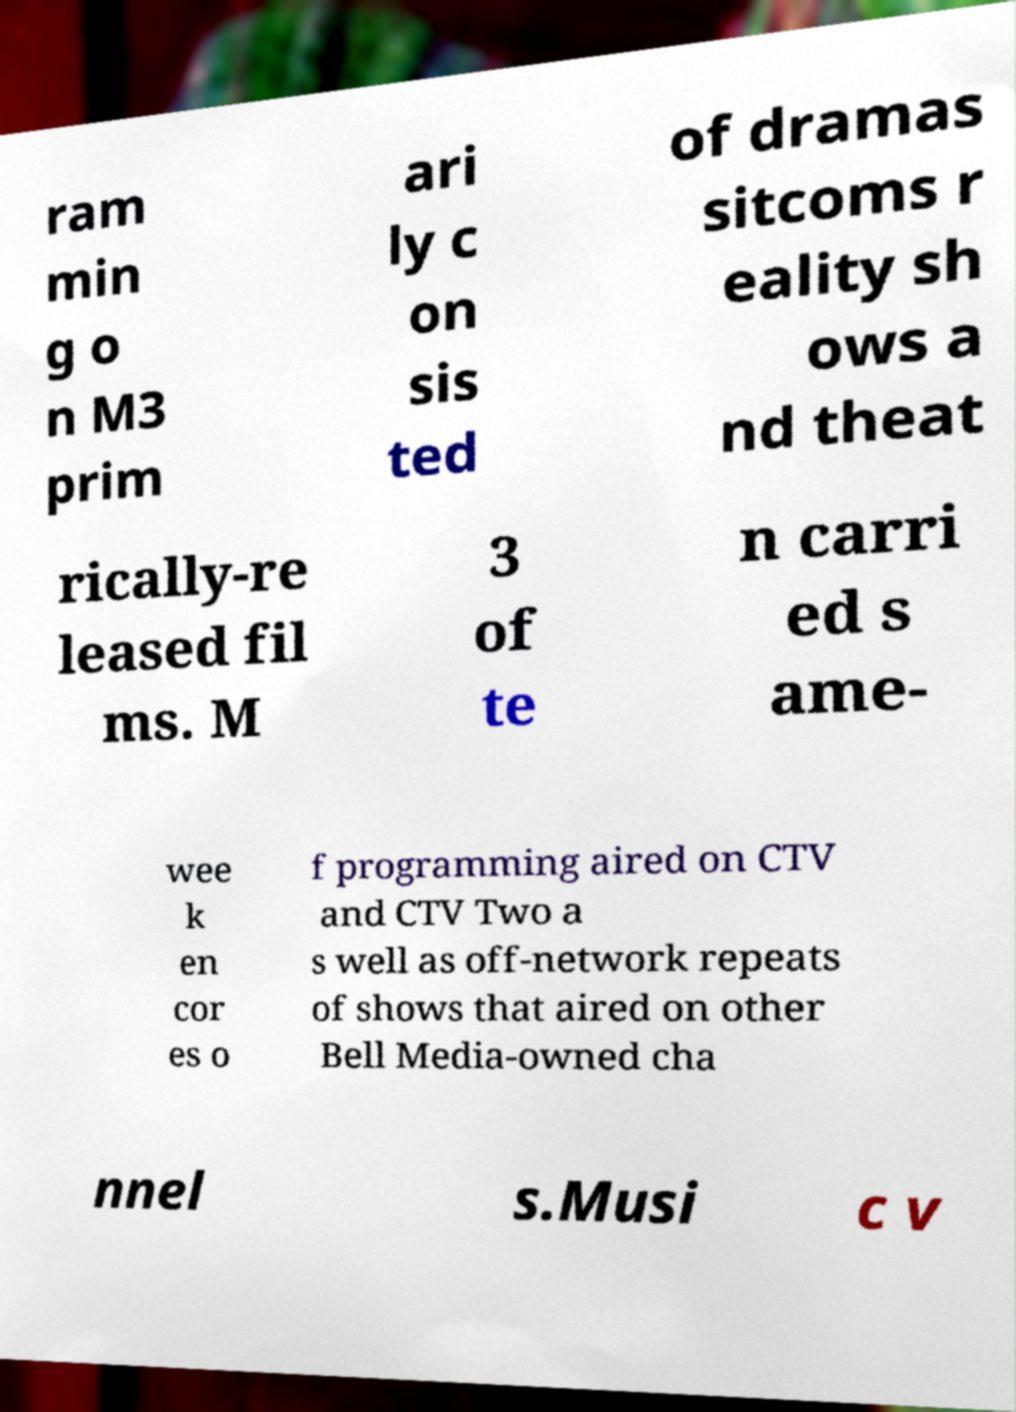Please read and relay the text visible in this image. What does it say? ram min g o n M3 prim ari ly c on sis ted of dramas sitcoms r eality sh ows a nd theat rically-re leased fil ms. M 3 of te n carri ed s ame- wee k en cor es o f programming aired on CTV and CTV Two a s well as off-network repeats of shows that aired on other Bell Media-owned cha nnel s.Musi c v 